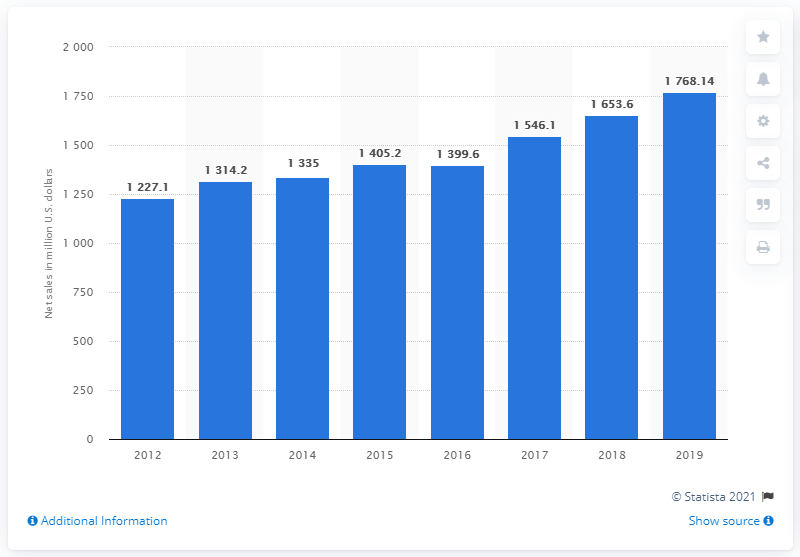Specify some key components in this picture. In 2019, Steve Madden's global net sales were 1,768.14 dollars. 